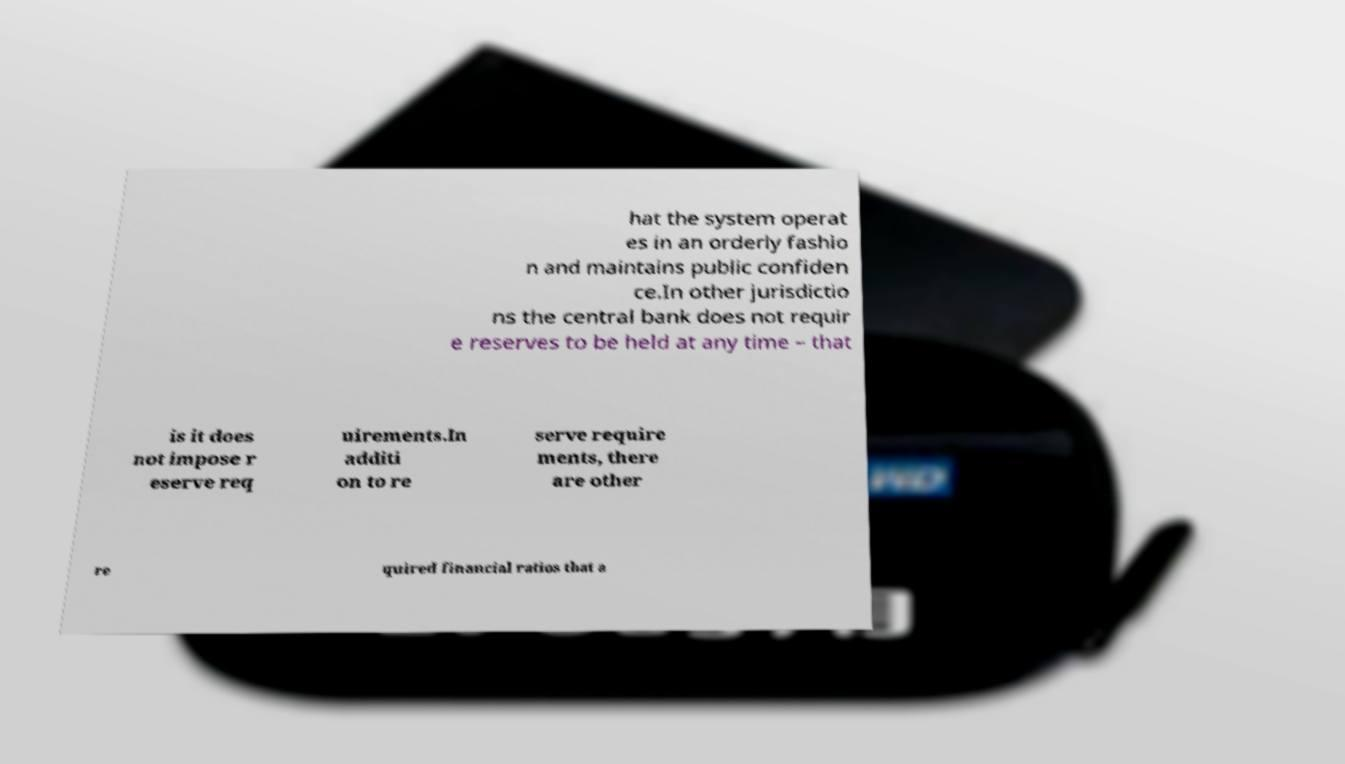There's text embedded in this image that I need extracted. Can you transcribe it verbatim? hat the system operat es in an orderly fashio n and maintains public confiden ce.In other jurisdictio ns the central bank does not requir e reserves to be held at any time – that is it does not impose r eserve req uirements.In additi on to re serve require ments, there are other re quired financial ratios that a 